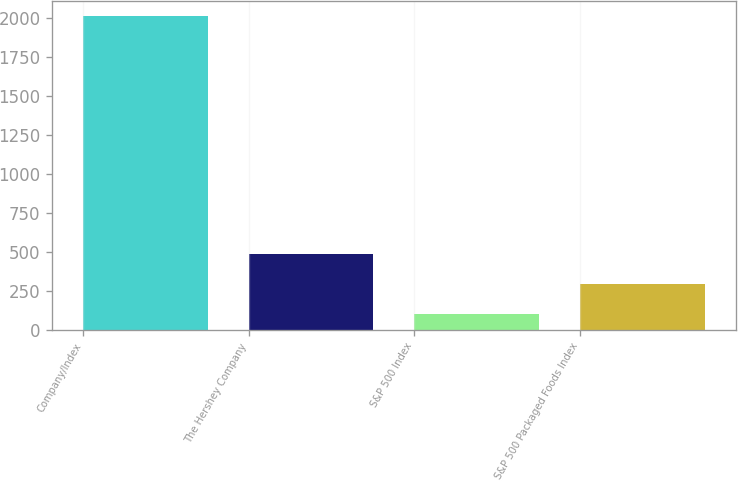Convert chart to OTSL. <chart><loc_0><loc_0><loc_500><loc_500><bar_chart><fcel>Company/Index<fcel>The Hershey Company<fcel>S&P 500 Index<fcel>S&P 500 Packaged Foods Index<nl><fcel>2011<fcel>483.8<fcel>102<fcel>292.9<nl></chart> 